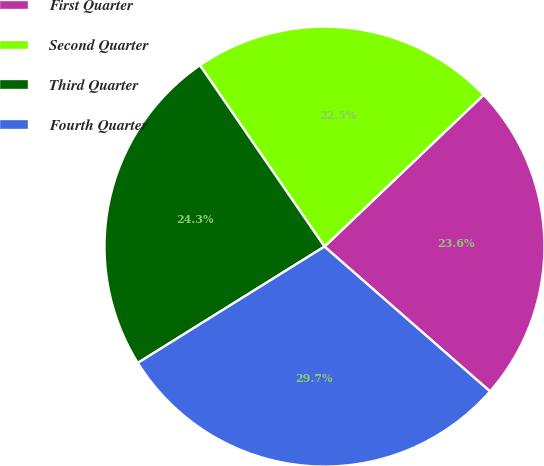Convert chart. <chart><loc_0><loc_0><loc_500><loc_500><pie_chart><fcel>First Quarter<fcel>Second Quarter<fcel>Third Quarter<fcel>Fourth Quarter<nl><fcel>23.56%<fcel>22.46%<fcel>24.29%<fcel>29.69%<nl></chart> 